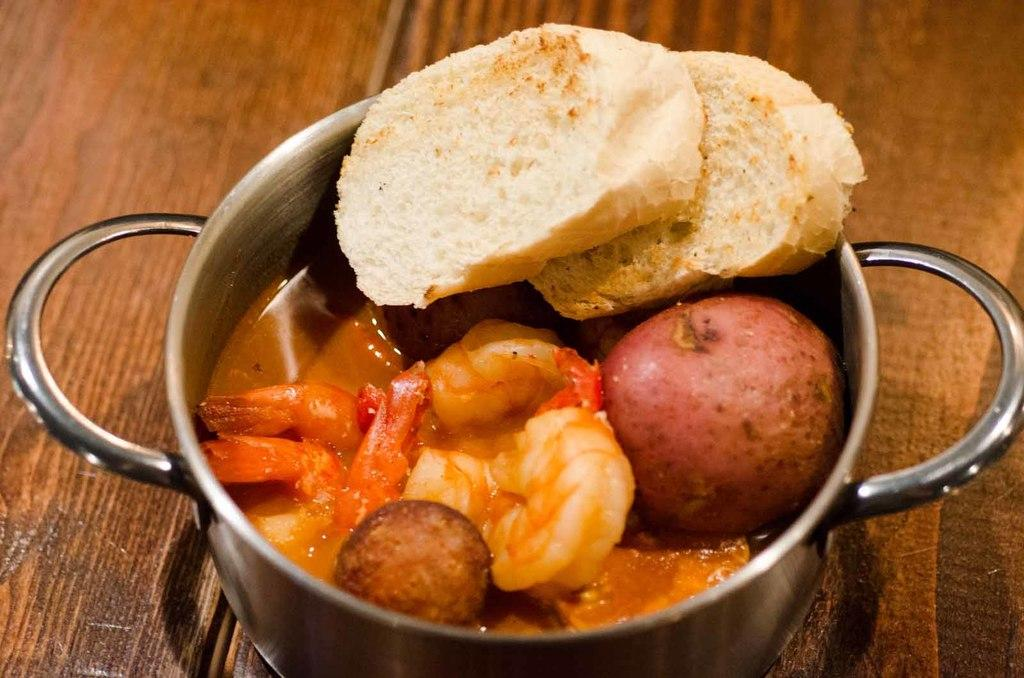What is the main object in the image? There is a pot in the image. What is inside the pot? The pot contains soup, prawns, vegetables, and breads. Where is the pot located? The pot is placed on a table. Can you see any knees in the image? There are no knees visible in the image; it features a pot with various ingredients on a table. 